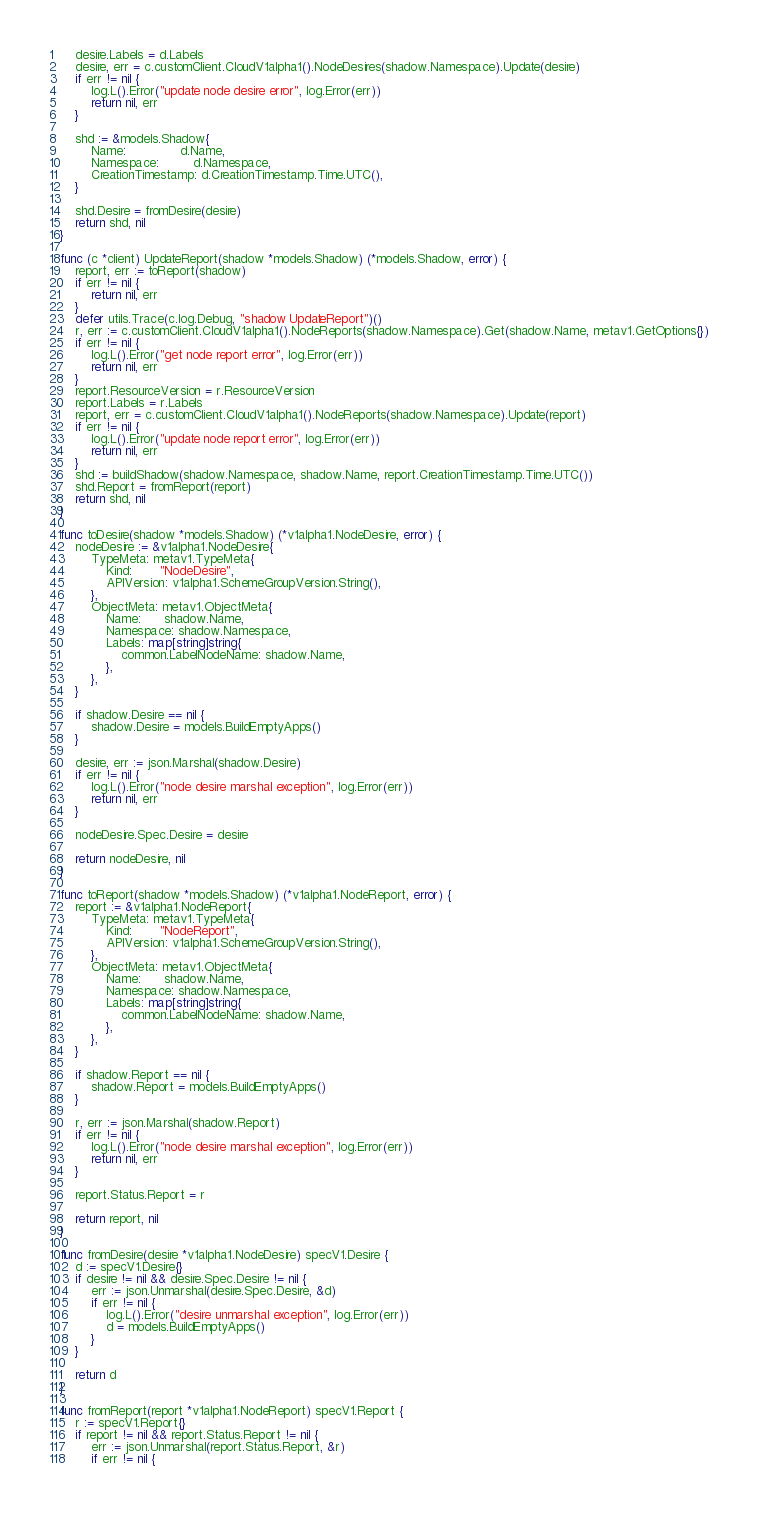<code> <loc_0><loc_0><loc_500><loc_500><_Go_>	desire.Labels = d.Labels
	desire, err = c.customClient.CloudV1alpha1().NodeDesires(shadow.Namespace).Update(desire)
	if err != nil {
		log.L().Error("update node desire error", log.Error(err))
		return nil, err
	}

	shd := &models.Shadow{
		Name:              d.Name,
		Namespace:         d.Namespace,
		CreationTimestamp: d.CreationTimestamp.Time.UTC(),
	}

	shd.Desire = fromDesire(desire)
	return shd, nil
}

func (c *client) UpdateReport(shadow *models.Shadow) (*models.Shadow, error) {
	report, err := toReport(shadow)
	if err != nil {
		return nil, err
	}
	defer utils.Trace(c.log.Debug, "shadow UpdateReport")()
	r, err := c.customClient.CloudV1alpha1().NodeReports(shadow.Namespace).Get(shadow.Name, metav1.GetOptions{})
	if err != nil {
		log.L().Error("get node report error", log.Error(err))
		return nil, err
	}
	report.ResourceVersion = r.ResourceVersion
	report.Labels = r.Labels
	report, err = c.customClient.CloudV1alpha1().NodeReports(shadow.Namespace).Update(report)
	if err != nil {
		log.L().Error("update node report error", log.Error(err))
		return nil, err
	}
	shd := buildShadow(shadow.Namespace, shadow.Name, report.CreationTimestamp.Time.UTC())
	shd.Report = fromReport(report)
	return shd, nil
}

func toDesire(shadow *models.Shadow) (*v1alpha1.NodeDesire, error) {
	nodeDesire := &v1alpha1.NodeDesire{
		TypeMeta: metav1.TypeMeta{
			Kind:       "NodeDesire",
			APIVersion: v1alpha1.SchemeGroupVersion.String(),
		},
		ObjectMeta: metav1.ObjectMeta{
			Name:      shadow.Name,
			Namespace: shadow.Namespace,
			Labels: map[string]string{
				common.LabelNodeName: shadow.Name,
			},
		},
	}

	if shadow.Desire == nil {
		shadow.Desire = models.BuildEmptyApps()
	}

	desire, err := json.Marshal(shadow.Desire)
	if err != nil {
		log.L().Error("node desire marshal exception", log.Error(err))
		return nil, err
	}

	nodeDesire.Spec.Desire = desire

	return nodeDesire, nil
}

func toReport(shadow *models.Shadow) (*v1alpha1.NodeReport, error) {
	report := &v1alpha1.NodeReport{
		TypeMeta: metav1.TypeMeta{
			Kind:       "NodeReport",
			APIVersion: v1alpha1.SchemeGroupVersion.String(),
		},
		ObjectMeta: metav1.ObjectMeta{
			Name:      shadow.Name,
			Namespace: shadow.Namespace,
			Labels: map[string]string{
				common.LabelNodeName: shadow.Name,
			},
		},
	}

	if shadow.Report == nil {
		shadow.Report = models.BuildEmptyApps()
	}

	r, err := json.Marshal(shadow.Report)
	if err != nil {
		log.L().Error("node desire marshal exception", log.Error(err))
		return nil, err
	}

	report.Status.Report = r

	return report, nil
}

func fromDesire(desire *v1alpha1.NodeDesire) specV1.Desire {
	d := specV1.Desire{}
	if desire != nil && desire.Spec.Desire != nil {
		err := json.Unmarshal(desire.Spec.Desire, &d)
		if err != nil {
			log.L().Error("desire unmarshal exception", log.Error(err))
			d = models.BuildEmptyApps()
		}
	}

	return d
}

func fromReport(report *v1alpha1.NodeReport) specV1.Report {
	r := specV1.Report{}
	if report != nil && report.Status.Report != nil {
		err := json.Unmarshal(report.Status.Report, &r)
		if err != nil {</code> 